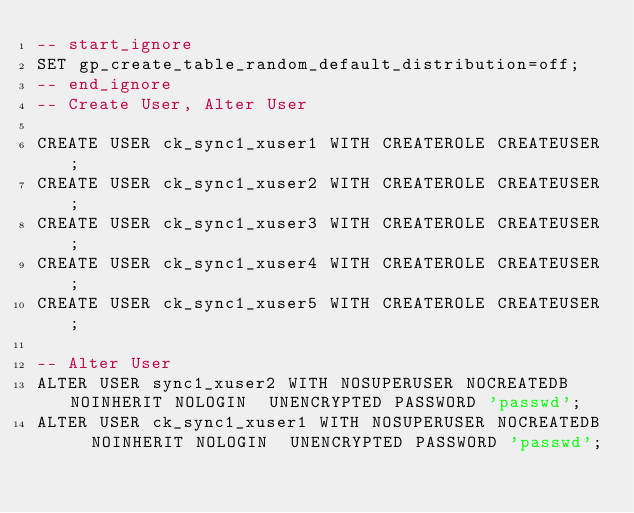<code> <loc_0><loc_0><loc_500><loc_500><_SQL_>-- start_ignore
SET gp_create_table_random_default_distribution=off;
-- end_ignore
-- Create User, Alter User

CREATE USER ck_sync1_xuser1 WITH CREATEROLE CREATEUSER;
CREATE USER ck_sync1_xuser2 WITH CREATEROLE CREATEUSER;
CREATE USER ck_sync1_xuser3 WITH CREATEROLE CREATEUSER;
CREATE USER ck_sync1_xuser4 WITH CREATEROLE CREATEUSER;
CREATE USER ck_sync1_xuser5 WITH CREATEROLE CREATEUSER;

-- Alter User
ALTER USER sync1_xuser2 WITH NOSUPERUSER NOCREATEDB  NOINHERIT NOLOGIN  UNENCRYPTED PASSWORD 'passwd';
ALTER USER ck_sync1_xuser1 WITH NOSUPERUSER NOCREATEDB  NOINHERIT NOLOGIN  UNENCRYPTED PASSWORD 'passwd';
</code> 